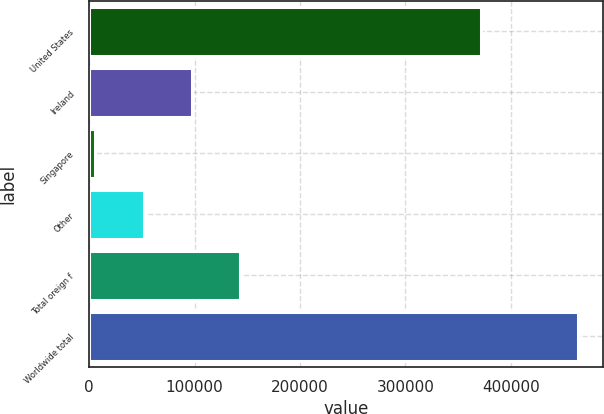<chart> <loc_0><loc_0><loc_500><loc_500><bar_chart><fcel>United States<fcel>Ireland<fcel>Singapore<fcel>Other<fcel>Total oreign f<fcel>Worldwide total<nl><fcel>371380<fcel>97380.6<fcel>5743<fcel>51561.8<fcel>143199<fcel>463931<nl></chart> 